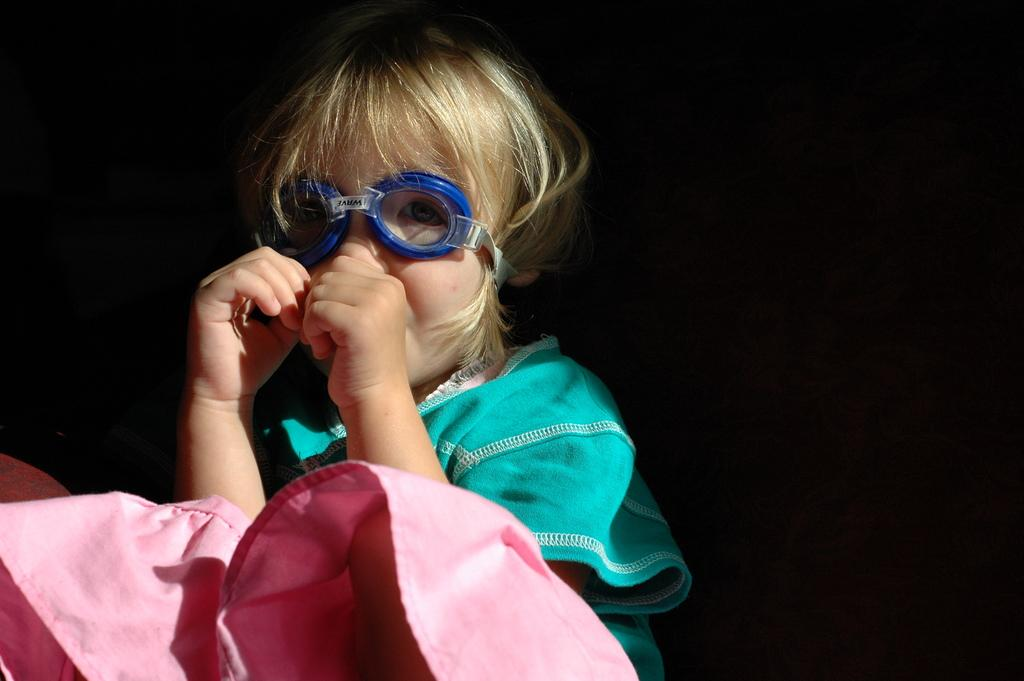What is the main subject of the picture? The main subject of the picture is a child. What is the child doing in the picture? The child is sitting and putting her thumb in her mouth. What accessory is the child wearing in the picture? The child is wearing goggles. What type of gun can be seen in the child's hand in the image? There is no gun present in the image; the child is putting her thumb in her mouth and wearing goggles. 